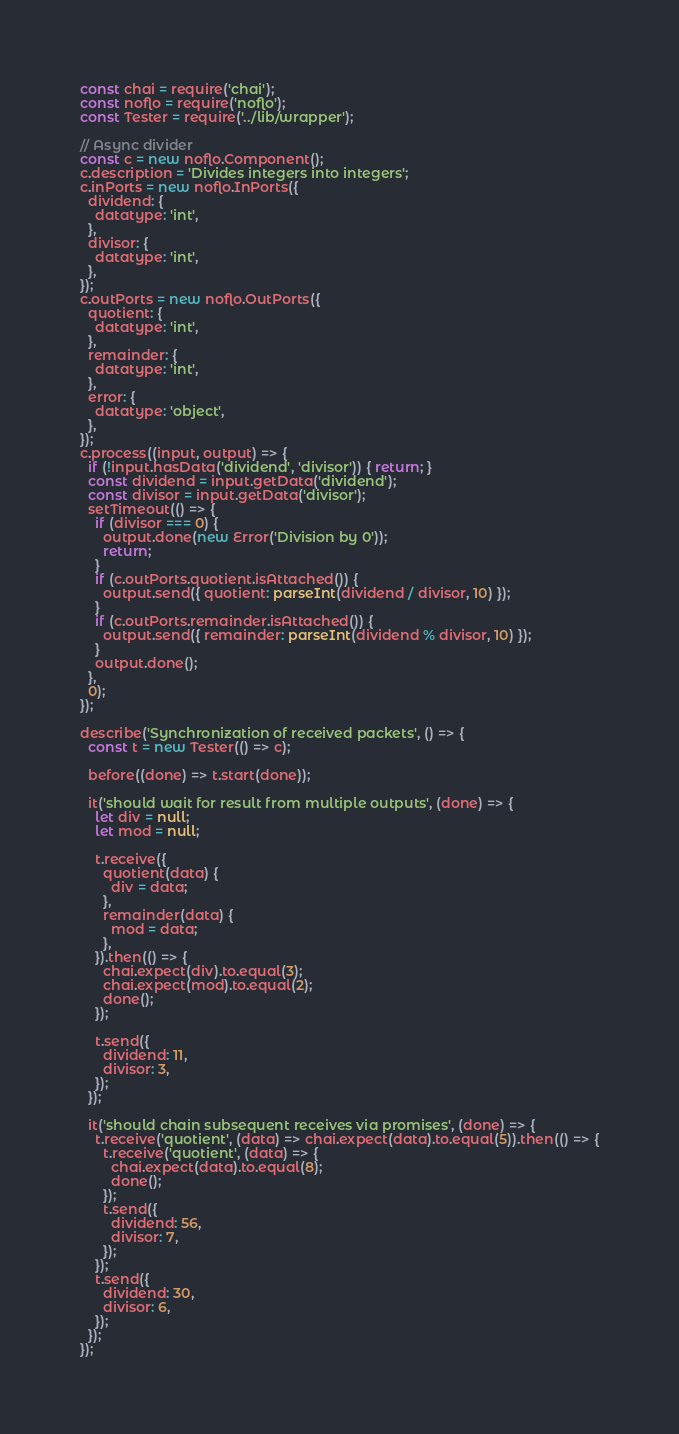<code> <loc_0><loc_0><loc_500><loc_500><_JavaScript_>const chai = require('chai');
const noflo = require('noflo');
const Tester = require('../lib/wrapper');

// Async divider
const c = new noflo.Component();
c.description = 'Divides integers into integers';
c.inPorts = new noflo.InPorts({
  dividend: {
    datatype: 'int',
  },
  divisor: {
    datatype: 'int',
  },
});
c.outPorts = new noflo.OutPorts({
  quotient: {
    datatype: 'int',
  },
  remainder: {
    datatype: 'int',
  },
  error: {
    datatype: 'object',
  },
});
c.process((input, output) => {
  if (!input.hasData('dividend', 'divisor')) { return; }
  const dividend = input.getData('dividend');
  const divisor = input.getData('divisor');
  setTimeout(() => {
    if (divisor === 0) {
      output.done(new Error('Division by 0'));
      return;
    }
    if (c.outPorts.quotient.isAttached()) {
      output.send({ quotient: parseInt(dividend / divisor, 10) });
    }
    if (c.outPorts.remainder.isAttached()) {
      output.send({ remainder: parseInt(dividend % divisor, 10) });
    }
    output.done();
  },
  0);
});

describe('Synchronization of received packets', () => {
  const t = new Tester(() => c);

  before((done) => t.start(done));

  it('should wait for result from multiple outputs', (done) => {
    let div = null;
    let mod = null;

    t.receive({
      quotient(data) {
        div = data;
      },
      remainder(data) {
        mod = data;
      },
    }).then(() => {
      chai.expect(div).to.equal(3);
      chai.expect(mod).to.equal(2);
      done();
    });

    t.send({
      dividend: 11,
      divisor: 3,
    });
  });

  it('should chain subsequent receives via promises', (done) => {
    t.receive('quotient', (data) => chai.expect(data).to.equal(5)).then(() => {
      t.receive('quotient', (data) => {
        chai.expect(data).to.equal(8);
        done();
      });
      t.send({
        dividend: 56,
        divisor: 7,
      });
    });
    t.send({
      dividend: 30,
      divisor: 6,
    });
  });
});
</code> 